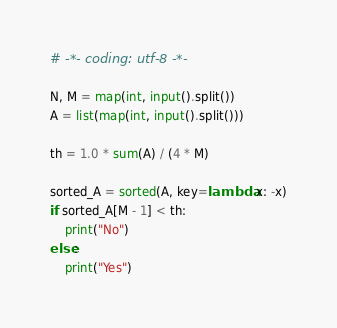Convert code to text. <code><loc_0><loc_0><loc_500><loc_500><_Python_># -*- coding: utf-8 -*-

N, M = map(int, input().split())
A = list(map(int, input().split()))

th = 1.0 * sum(A) / (4 * M)

sorted_A = sorted(A, key=lambda x: -x)
if sorted_A[M - 1] < th:
    print("No")
else:
    print("Yes")
</code> 